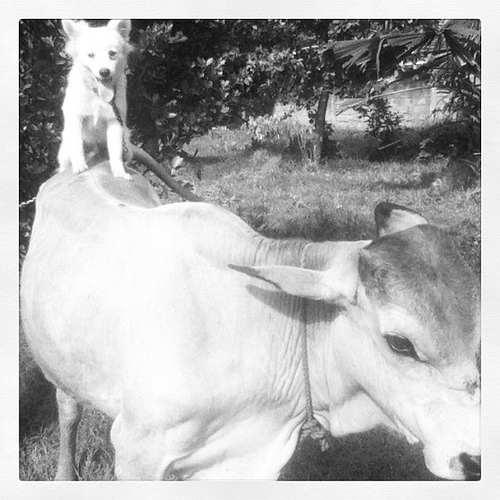What can you tell me about the surroundings in the image? The photo depicts a rural setting with lush greenery in the background, likely a pasture or farm where animals have plenty of space to roam and interact. Does the environment look well-suited for these animals? Yes, the surroundings seem peaceful and natural, providing a safe and comfortable habitat for the cow and dog to live and possibly establish an unusual companionship. 